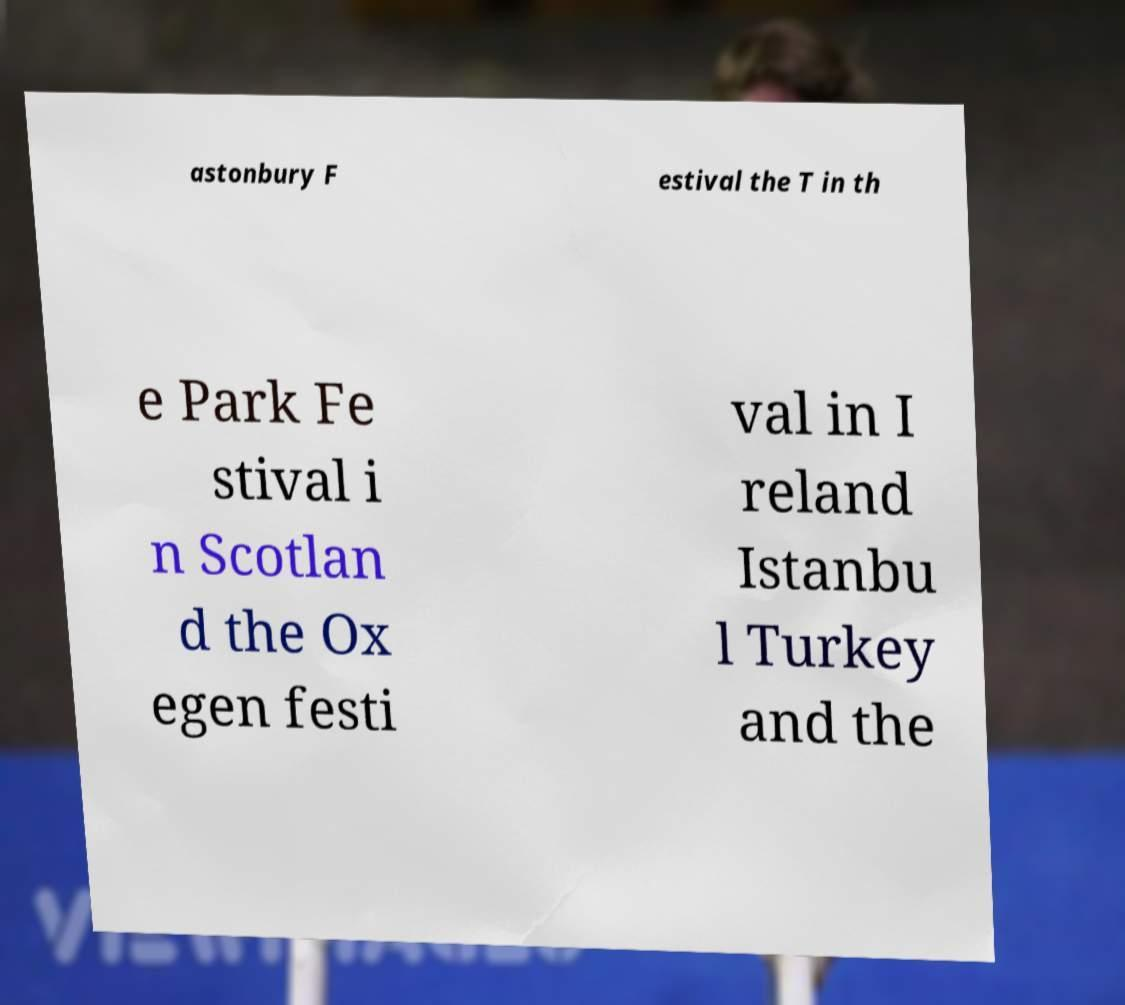There's text embedded in this image that I need extracted. Can you transcribe it verbatim? astonbury F estival the T in th e Park Fe stival i n Scotlan d the Ox egen festi val in I reland Istanbu l Turkey and the 